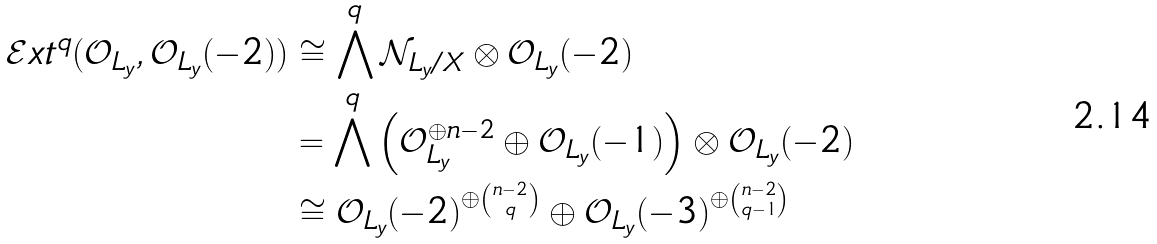<formula> <loc_0><loc_0><loc_500><loc_500>\mathcal { E } x t ^ { q } ( \mathcal { O } _ { L _ { y } } , \mathcal { O } _ { L _ { y } } ( - 2 ) ) & \cong \bigwedge ^ { q } \mathcal { N } _ { L _ { y } / X } \otimes \mathcal { O } _ { L _ { y } } ( - 2 ) \\ & = \bigwedge ^ { q } \left ( \mathcal { O } _ { L _ { y } } ^ { \oplus n - 2 } \oplus \mathcal { O } _ { L _ { y } } ( - 1 ) \right ) \otimes \mathcal { O } _ { L _ { y } } ( - 2 ) \\ & \cong \mathcal { O } _ { L _ { y } } ( - 2 ) ^ { \oplus \binom { n - 2 } { q } } \oplus \mathcal { O } _ { L _ { y } } ( - 3 ) ^ { \oplus \binom { n - 2 } { q - 1 } }</formula> 